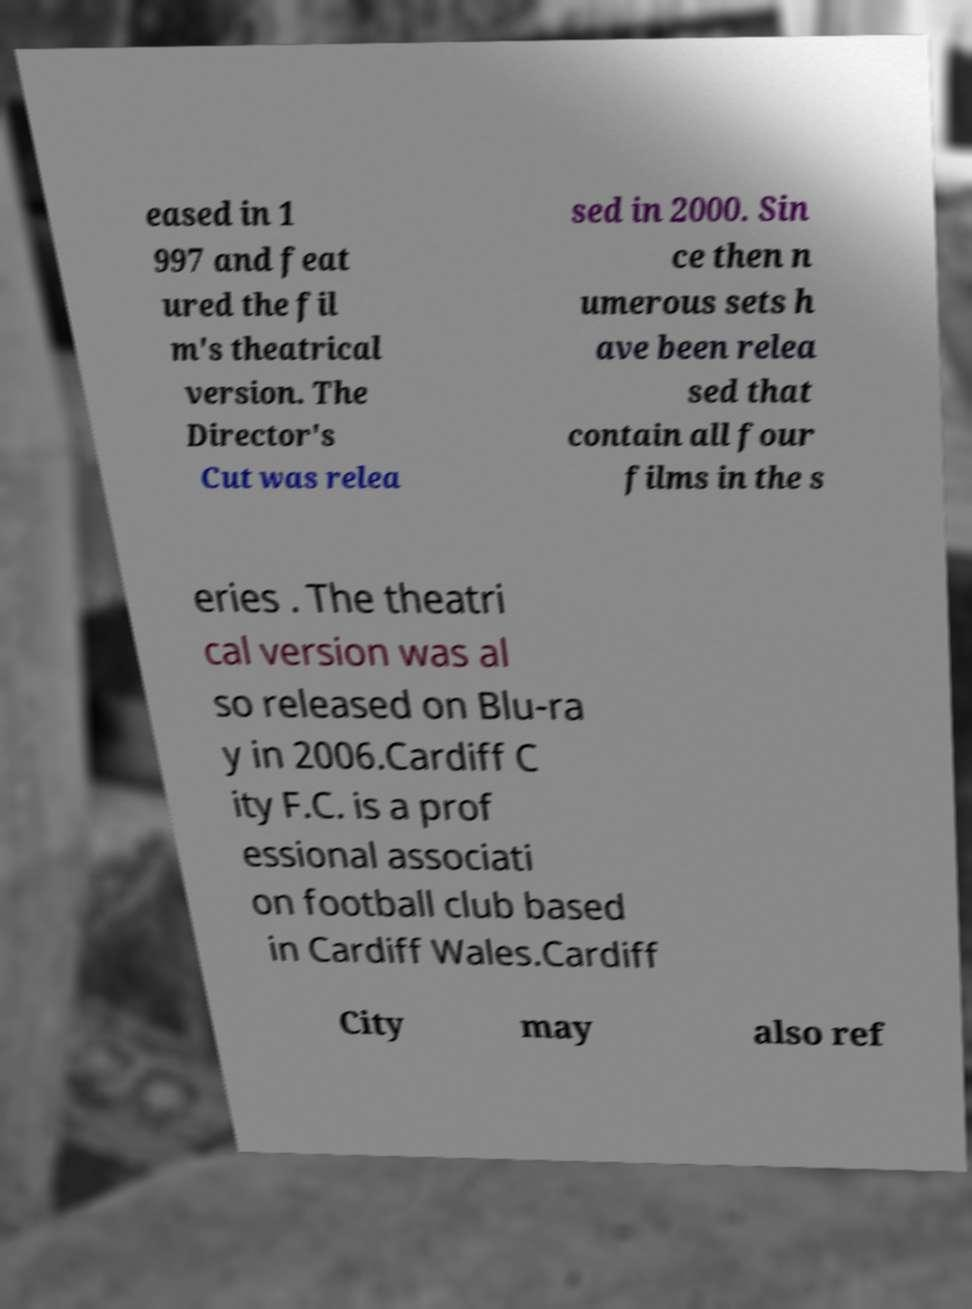I need the written content from this picture converted into text. Can you do that? eased in 1 997 and feat ured the fil m's theatrical version. The Director's Cut was relea sed in 2000. Sin ce then n umerous sets h ave been relea sed that contain all four films in the s eries . The theatri cal version was al so released on Blu-ra y in 2006.Cardiff C ity F.C. is a prof essional associati on football club based in Cardiff Wales.Cardiff City may also ref 